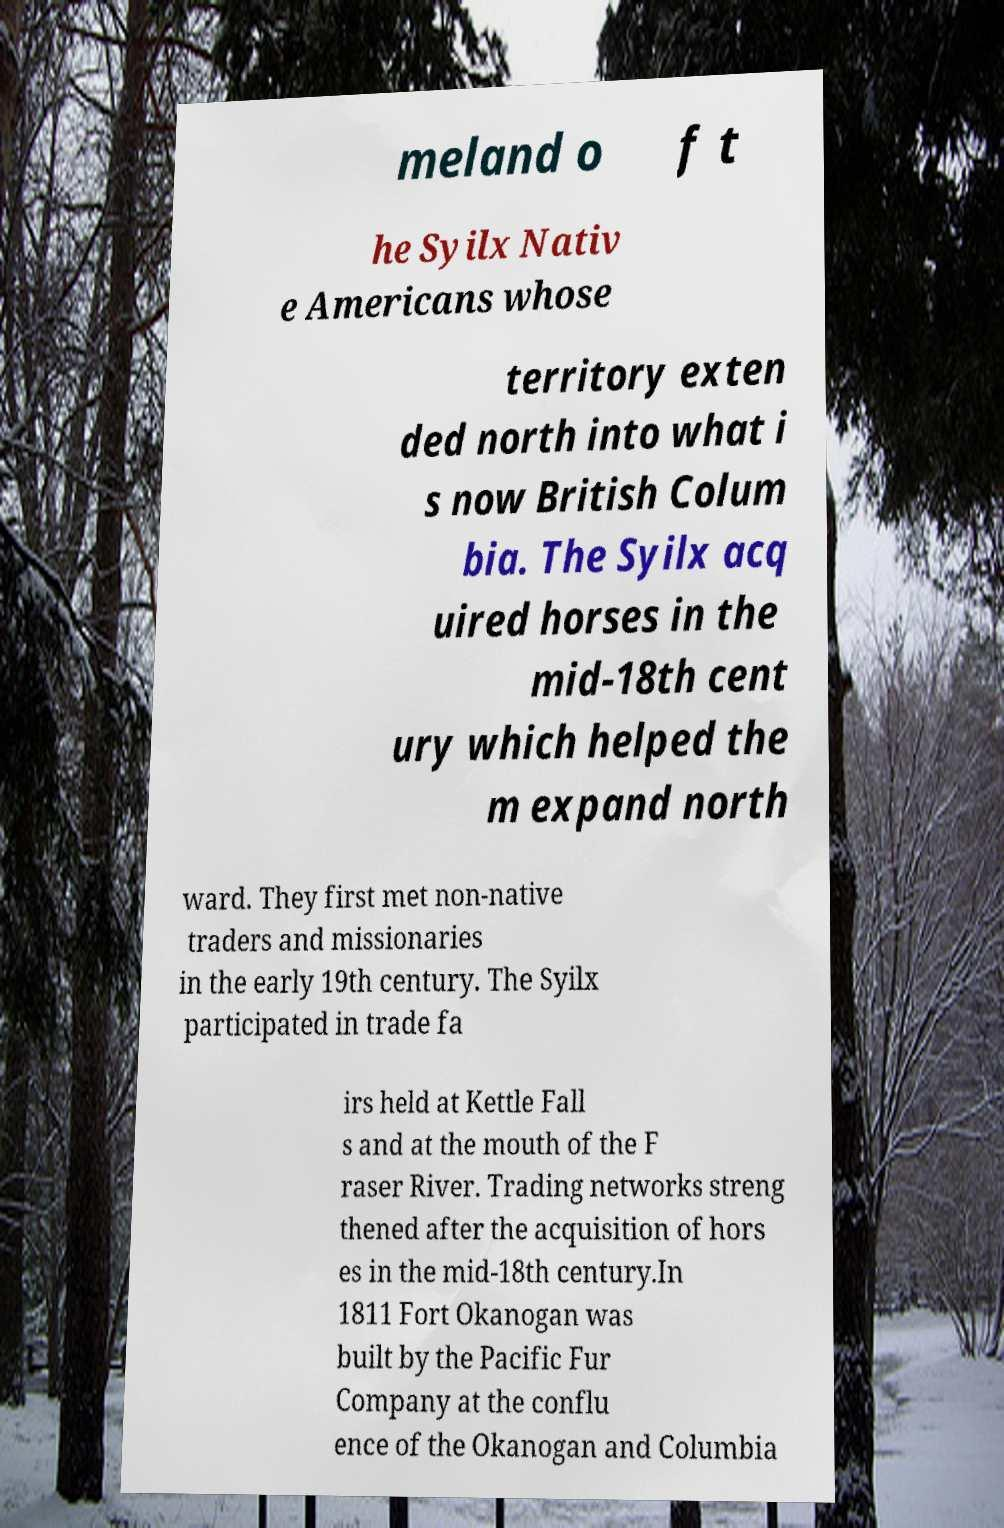Could you assist in decoding the text presented in this image and type it out clearly? meland o f t he Syilx Nativ e Americans whose territory exten ded north into what i s now British Colum bia. The Syilx acq uired horses in the mid-18th cent ury which helped the m expand north ward. They first met non-native traders and missionaries in the early 19th century. The Syilx participated in trade fa irs held at Kettle Fall s and at the mouth of the F raser River. Trading networks streng thened after the acquisition of hors es in the mid-18th century.In 1811 Fort Okanogan was built by the Pacific Fur Company at the conflu ence of the Okanogan and Columbia 